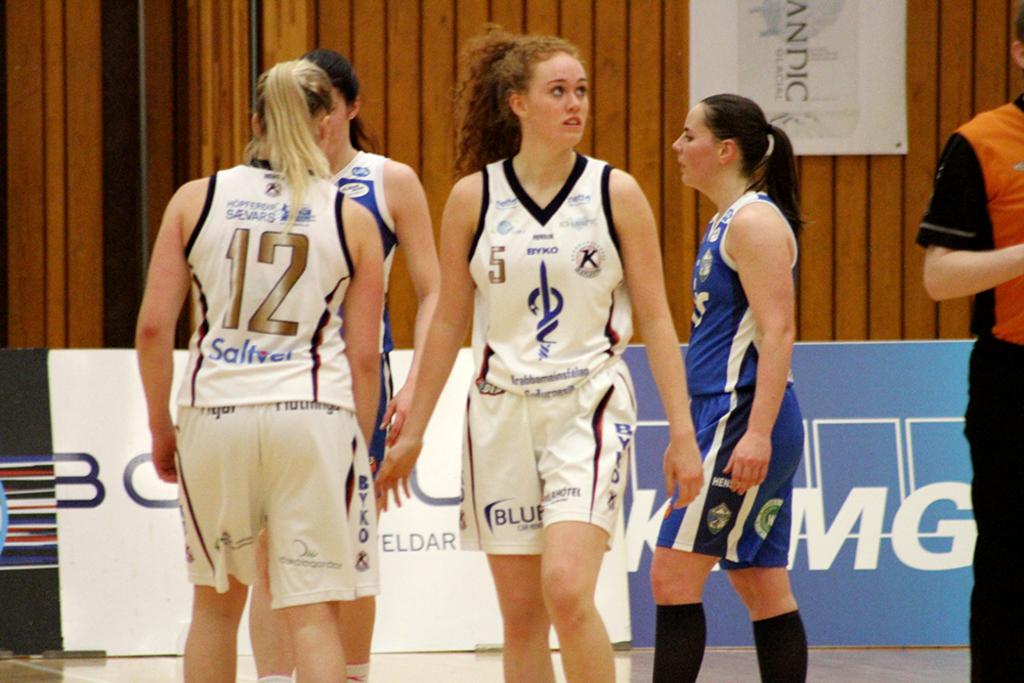What is the number of the girl facing the camera?
Provide a short and direct response. 5. 